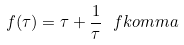Convert formula to latex. <formula><loc_0><loc_0><loc_500><loc_500>f ( \tau ) = \tau + \frac { 1 } { \tau } \ f k o m m a</formula> 